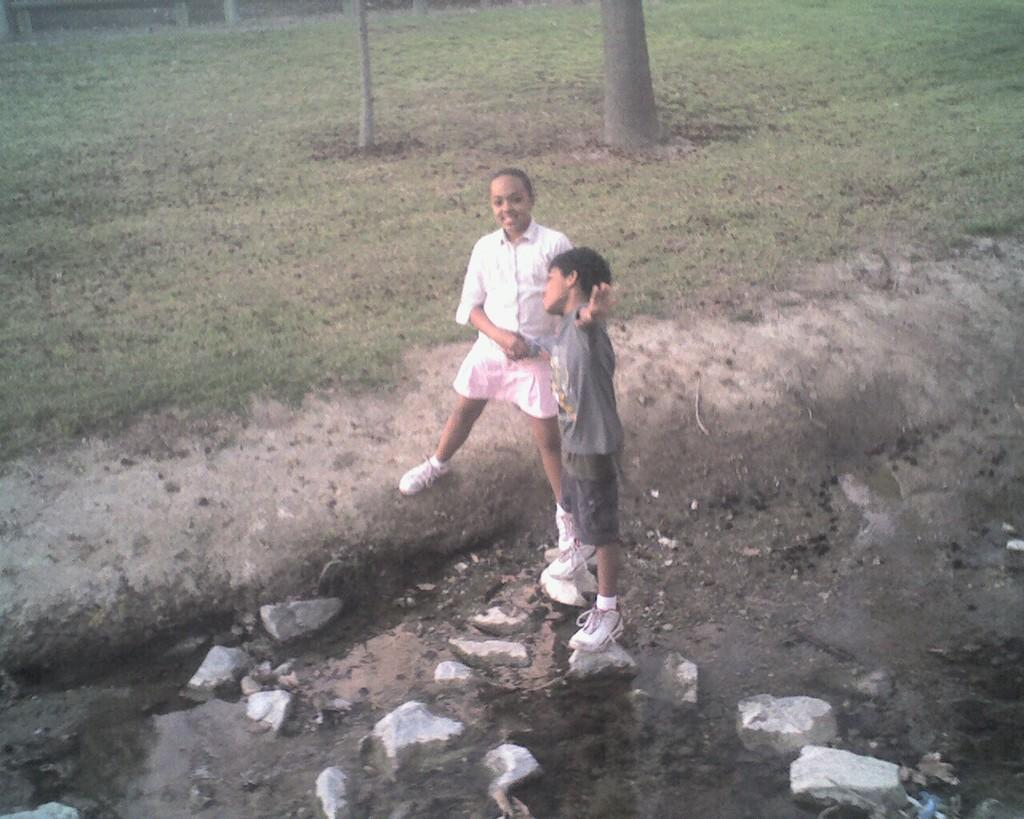How many people are in the image? There are two persons standing in the image. What is at the bottom of the image? There are rocks at the bottom of the image. What can be seen in the background of the image? Tree trunks and grass are visible in the background of the image. What type of collar is the tree wearing in the image? There are no collars present in the image, as trees do not wear collars. What material is the silk used for in the image? There is no silk present in the image, so it cannot be determined what material it might be used for. 